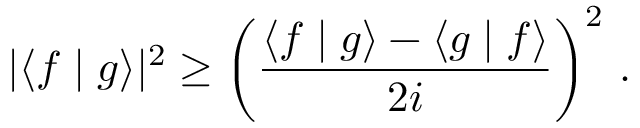<formula> <loc_0><loc_0><loc_500><loc_500>| \langle f | g \rangle | ^ { 2 } \geq { \left ( } { \frac { \langle f | g \rangle - \langle g | f \rangle } { 2 i } } { \right ) } ^ { 2 } .</formula> 